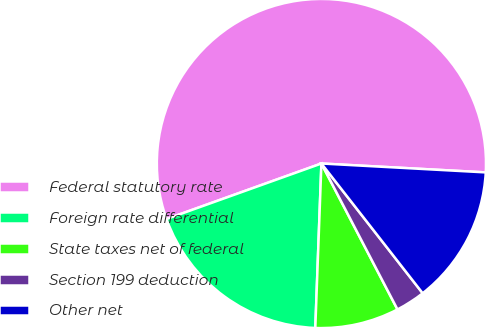Convert chart. <chart><loc_0><loc_0><loc_500><loc_500><pie_chart><fcel>Federal statutory rate<fcel>Foreign rate differential<fcel>State taxes net of federal<fcel>Section 199 deduction<fcel>Other net<nl><fcel>56.34%<fcel>18.93%<fcel>8.24%<fcel>2.9%<fcel>13.59%<nl></chart> 